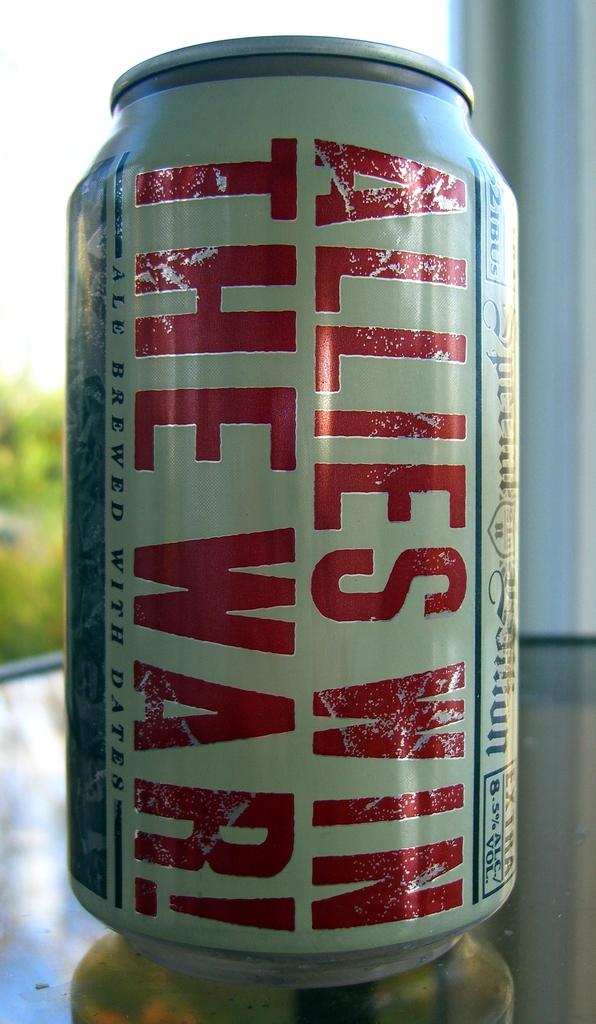What are the words on the can?
Provide a succinct answer. Allies win the war!. What is this brand of drink?
Offer a terse response. Unanswerable. 